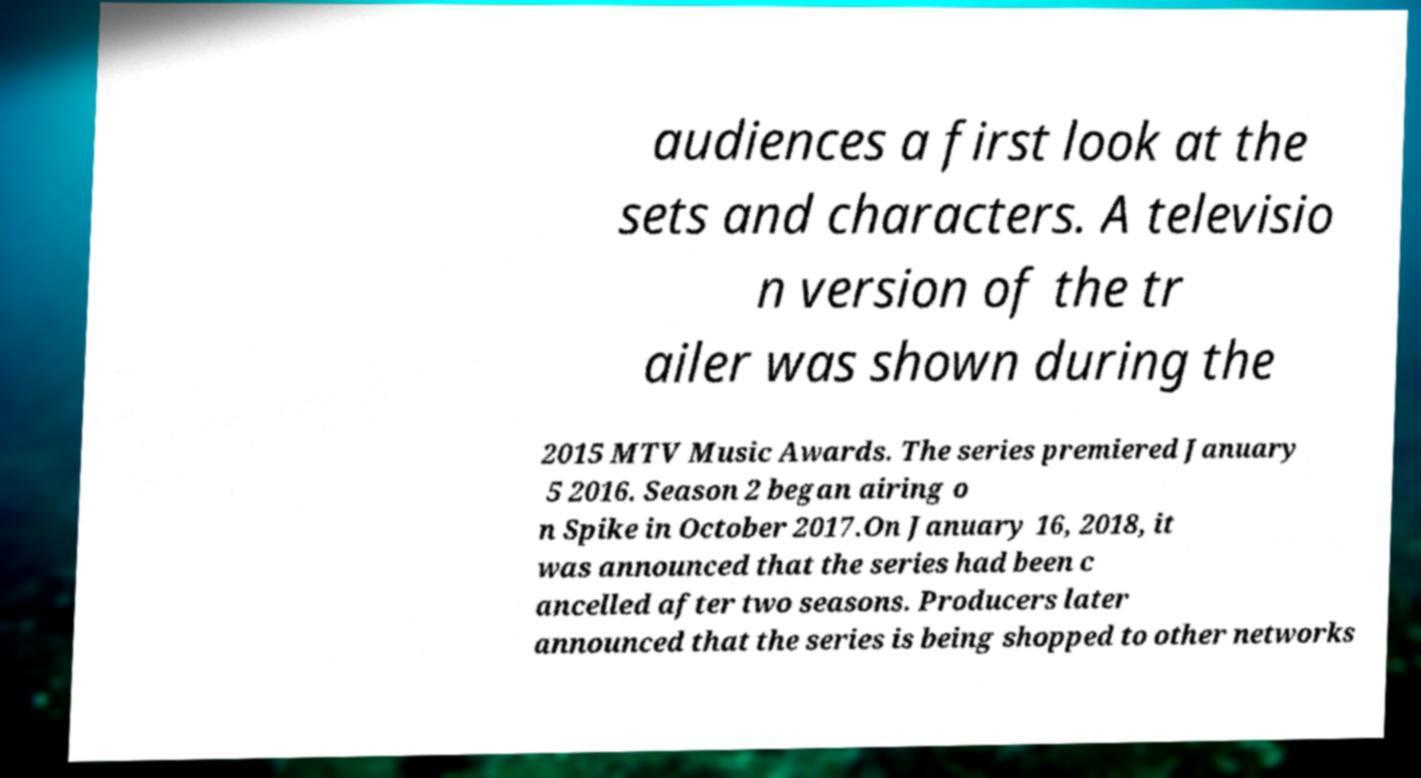Could you assist in decoding the text presented in this image and type it out clearly? audiences a first look at the sets and characters. A televisio n version of the tr ailer was shown during the 2015 MTV Music Awards. The series premiered January 5 2016. Season 2 began airing o n Spike in October 2017.On January 16, 2018, it was announced that the series had been c ancelled after two seasons. Producers later announced that the series is being shopped to other networks 